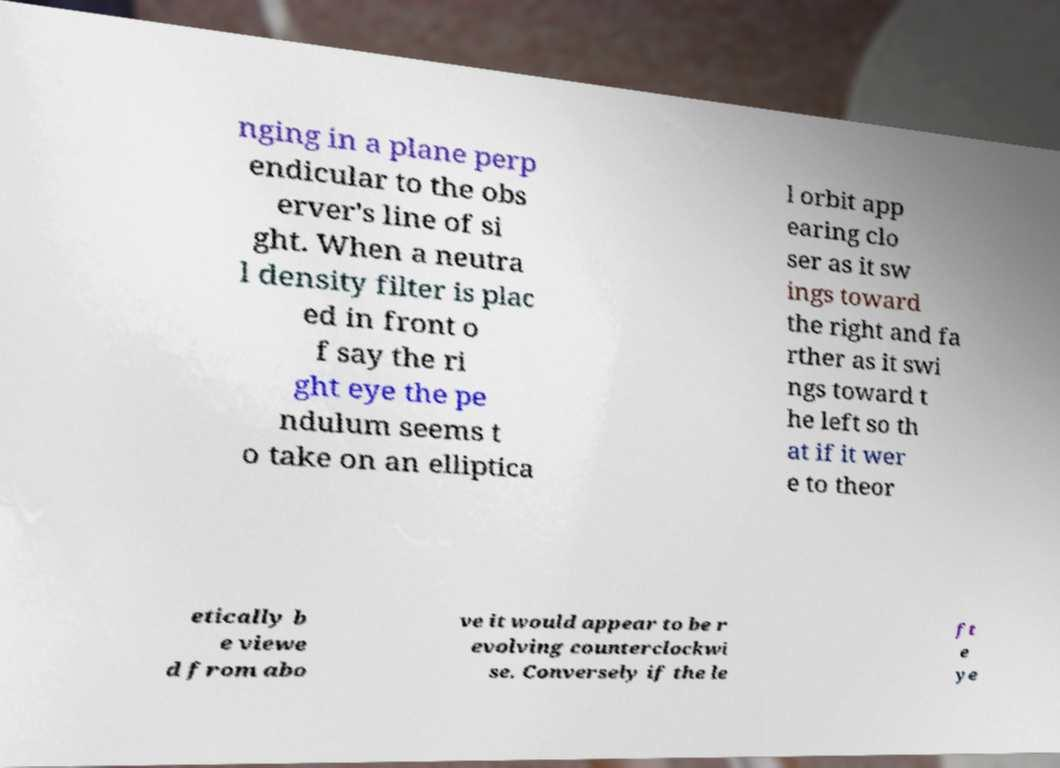Could you assist in decoding the text presented in this image and type it out clearly? nging in a plane perp endicular to the obs erver's line of si ght. When a neutra l density filter is plac ed in front o f say the ri ght eye the pe ndulum seems t o take on an elliptica l orbit app earing clo ser as it sw ings toward the right and fa rther as it swi ngs toward t he left so th at if it wer e to theor etically b e viewe d from abo ve it would appear to be r evolving counterclockwi se. Conversely if the le ft e ye 